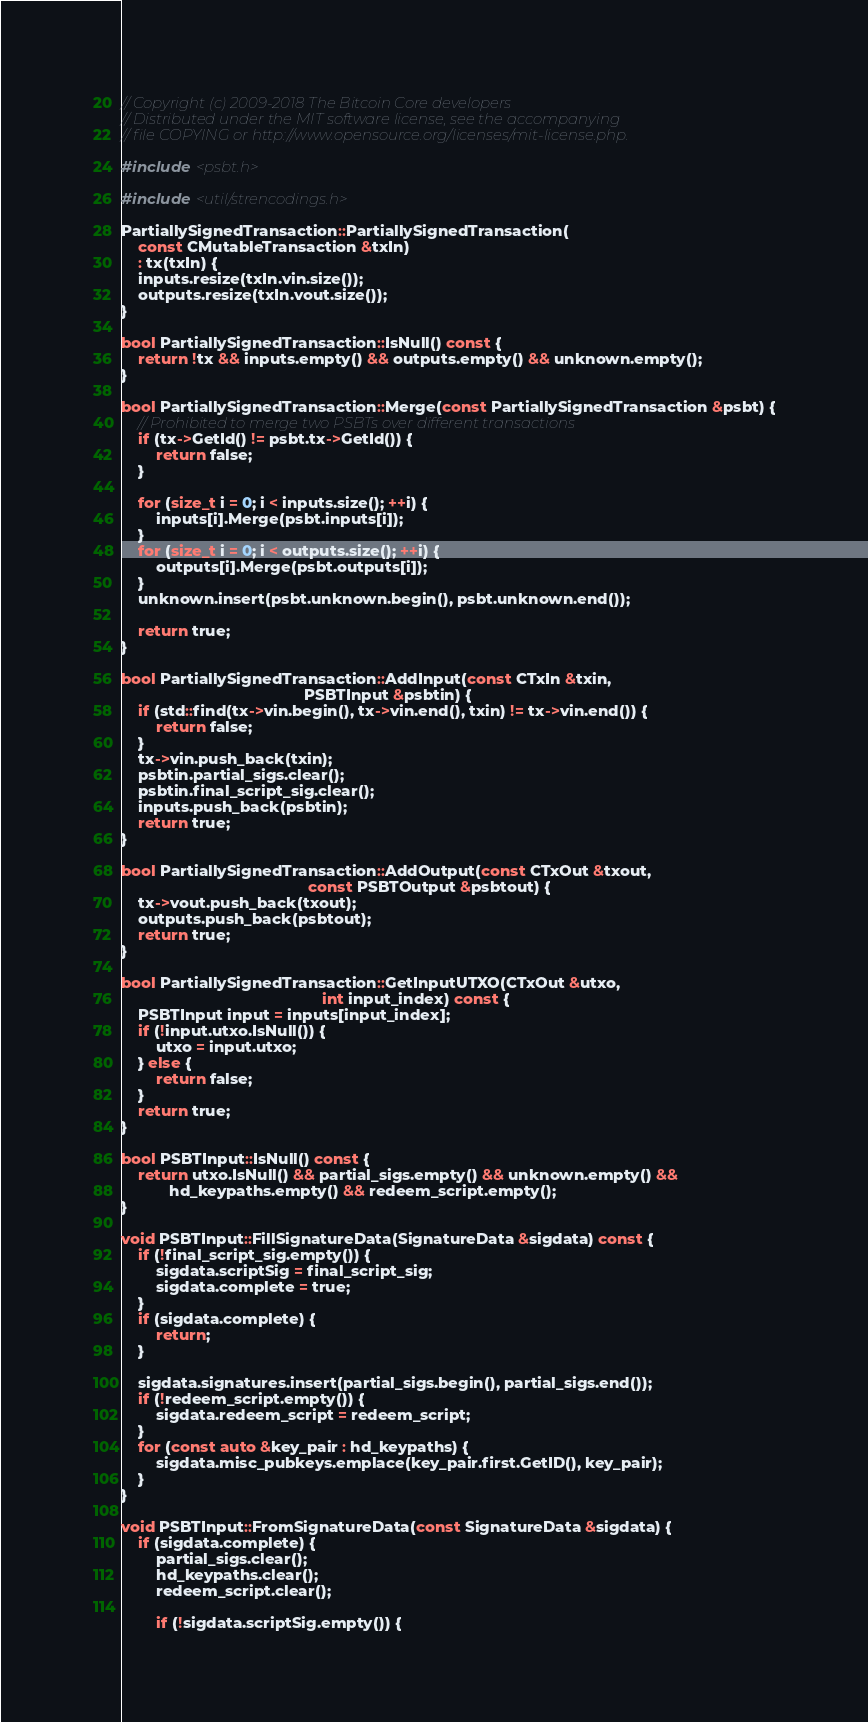Convert code to text. <code><loc_0><loc_0><loc_500><loc_500><_C++_>// Copyright (c) 2009-2018 The Bitcoin Core developers
// Distributed under the MIT software license, see the accompanying
// file COPYING or http://www.opensource.org/licenses/mit-license.php.

#include <psbt.h>

#include <util/strencodings.h>

PartiallySignedTransaction::PartiallySignedTransaction(
    const CMutableTransaction &txIn)
    : tx(txIn) {
    inputs.resize(txIn.vin.size());
    outputs.resize(txIn.vout.size());
}

bool PartiallySignedTransaction::IsNull() const {
    return !tx && inputs.empty() && outputs.empty() && unknown.empty();
}

bool PartiallySignedTransaction::Merge(const PartiallySignedTransaction &psbt) {
    // Prohibited to merge two PSBTs over different transactions
    if (tx->GetId() != psbt.tx->GetId()) {
        return false;
    }

    for (size_t i = 0; i < inputs.size(); ++i) {
        inputs[i].Merge(psbt.inputs[i]);
    }
    for (size_t i = 0; i < outputs.size(); ++i) {
        outputs[i].Merge(psbt.outputs[i]);
    }
    unknown.insert(psbt.unknown.begin(), psbt.unknown.end());

    return true;
}

bool PartiallySignedTransaction::AddInput(const CTxIn &txin,
                                          PSBTInput &psbtin) {
    if (std::find(tx->vin.begin(), tx->vin.end(), txin) != tx->vin.end()) {
        return false;
    }
    tx->vin.push_back(txin);
    psbtin.partial_sigs.clear();
    psbtin.final_script_sig.clear();
    inputs.push_back(psbtin);
    return true;
}

bool PartiallySignedTransaction::AddOutput(const CTxOut &txout,
                                           const PSBTOutput &psbtout) {
    tx->vout.push_back(txout);
    outputs.push_back(psbtout);
    return true;
}

bool PartiallySignedTransaction::GetInputUTXO(CTxOut &utxo,
                                              int input_index) const {
    PSBTInput input = inputs[input_index];
    if (!input.utxo.IsNull()) {
        utxo = input.utxo;
    } else {
        return false;
    }
    return true;
}

bool PSBTInput::IsNull() const {
    return utxo.IsNull() && partial_sigs.empty() && unknown.empty() &&
           hd_keypaths.empty() && redeem_script.empty();
}

void PSBTInput::FillSignatureData(SignatureData &sigdata) const {
    if (!final_script_sig.empty()) {
        sigdata.scriptSig = final_script_sig;
        sigdata.complete = true;
    }
    if (sigdata.complete) {
        return;
    }

    sigdata.signatures.insert(partial_sigs.begin(), partial_sigs.end());
    if (!redeem_script.empty()) {
        sigdata.redeem_script = redeem_script;
    }
    for (const auto &key_pair : hd_keypaths) {
        sigdata.misc_pubkeys.emplace(key_pair.first.GetID(), key_pair);
    }
}

void PSBTInput::FromSignatureData(const SignatureData &sigdata) {
    if (sigdata.complete) {
        partial_sigs.clear();
        hd_keypaths.clear();
        redeem_script.clear();

        if (!sigdata.scriptSig.empty()) {</code> 